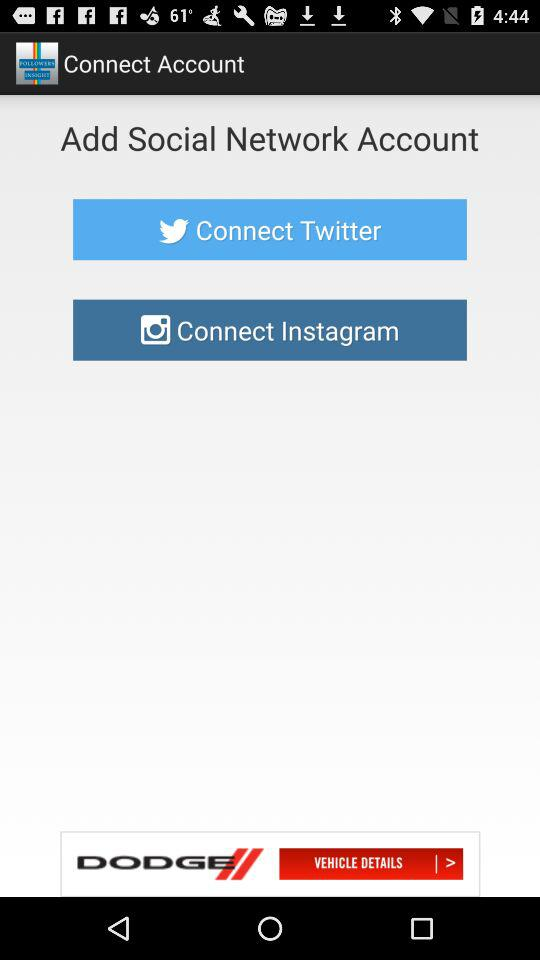Which are the 2 social network accounts available to connect? The 2 social network accounts are "Twitter" and "Facebook". 